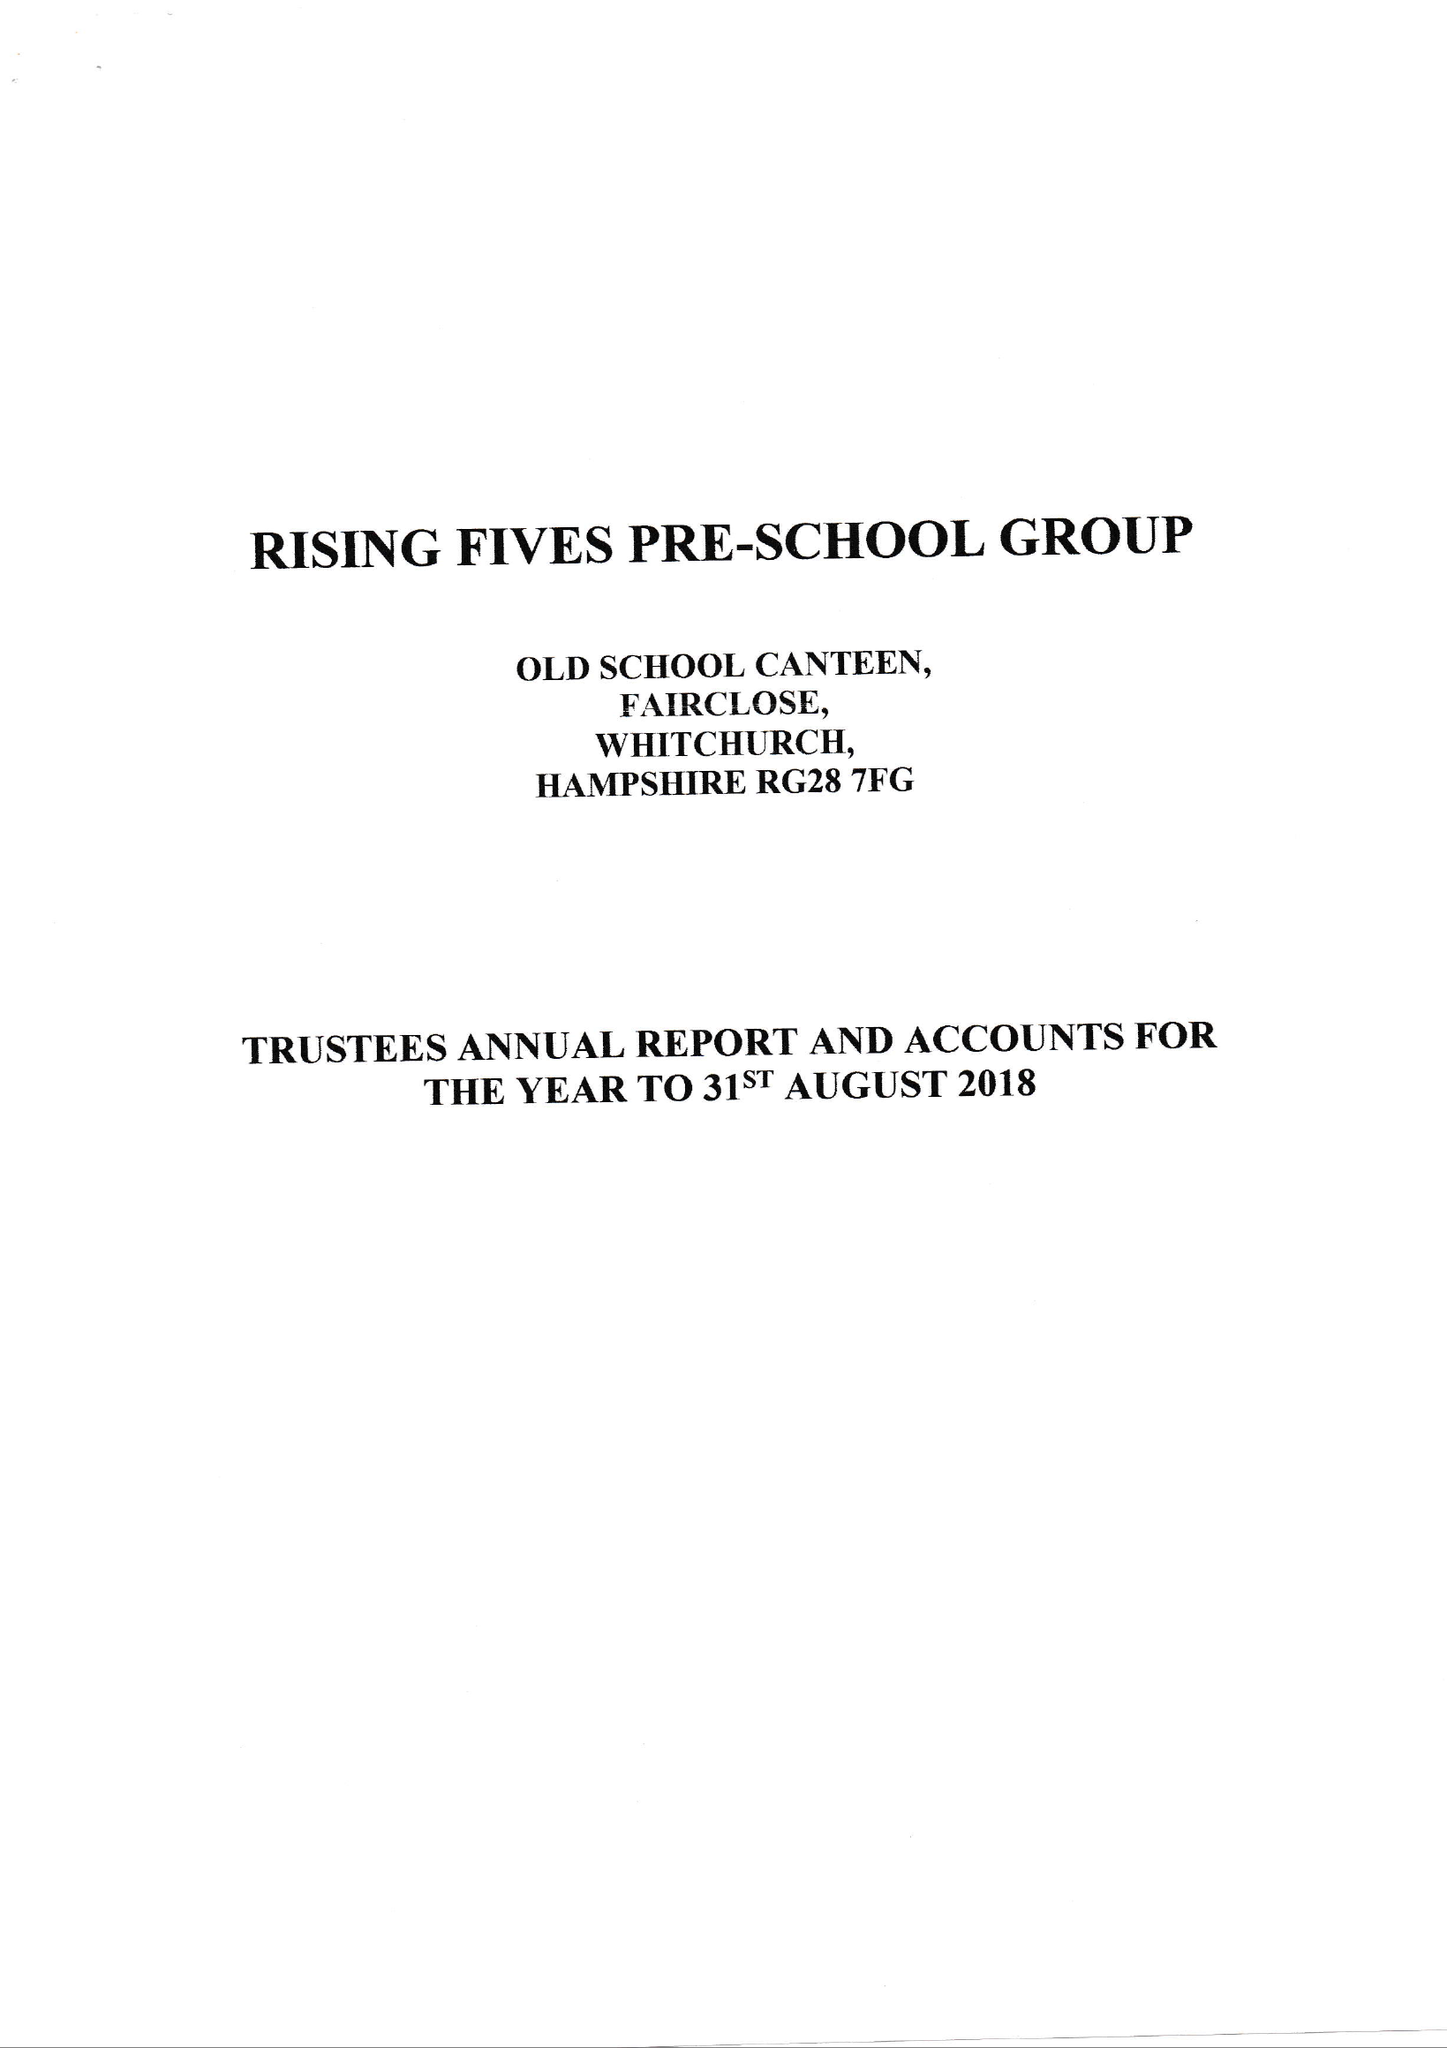What is the value for the report_date?
Answer the question using a single word or phrase. 2018-08-31 